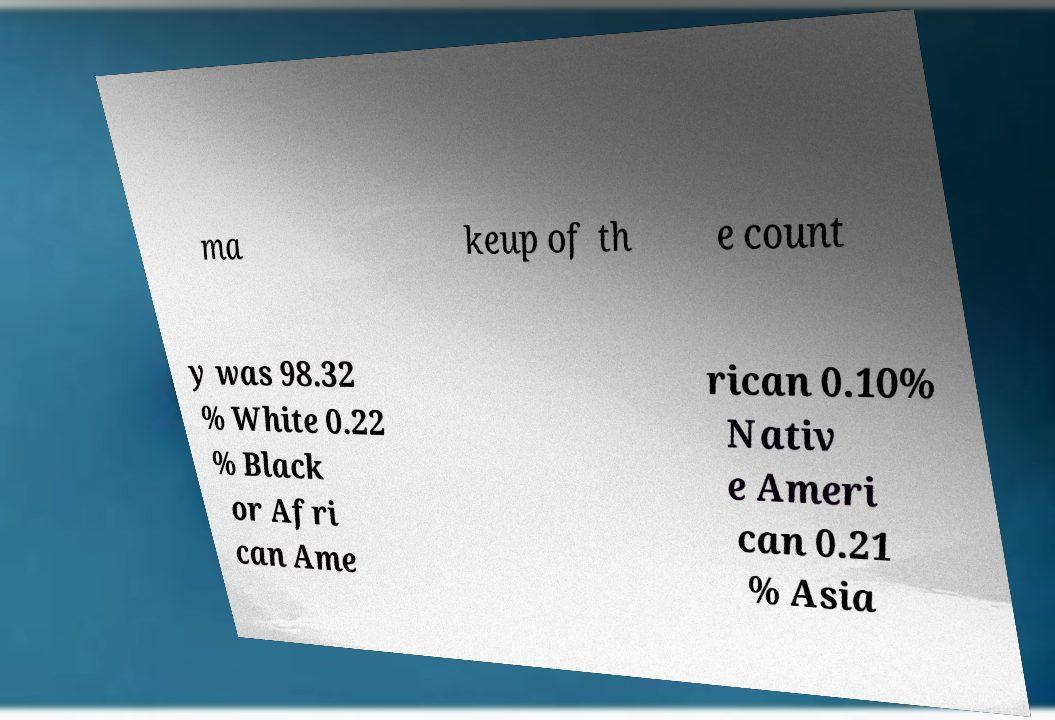Please read and relay the text visible in this image. What does it say? ma keup of th e count y was 98.32 % White 0.22 % Black or Afri can Ame rican 0.10% Nativ e Ameri can 0.21 % Asia 